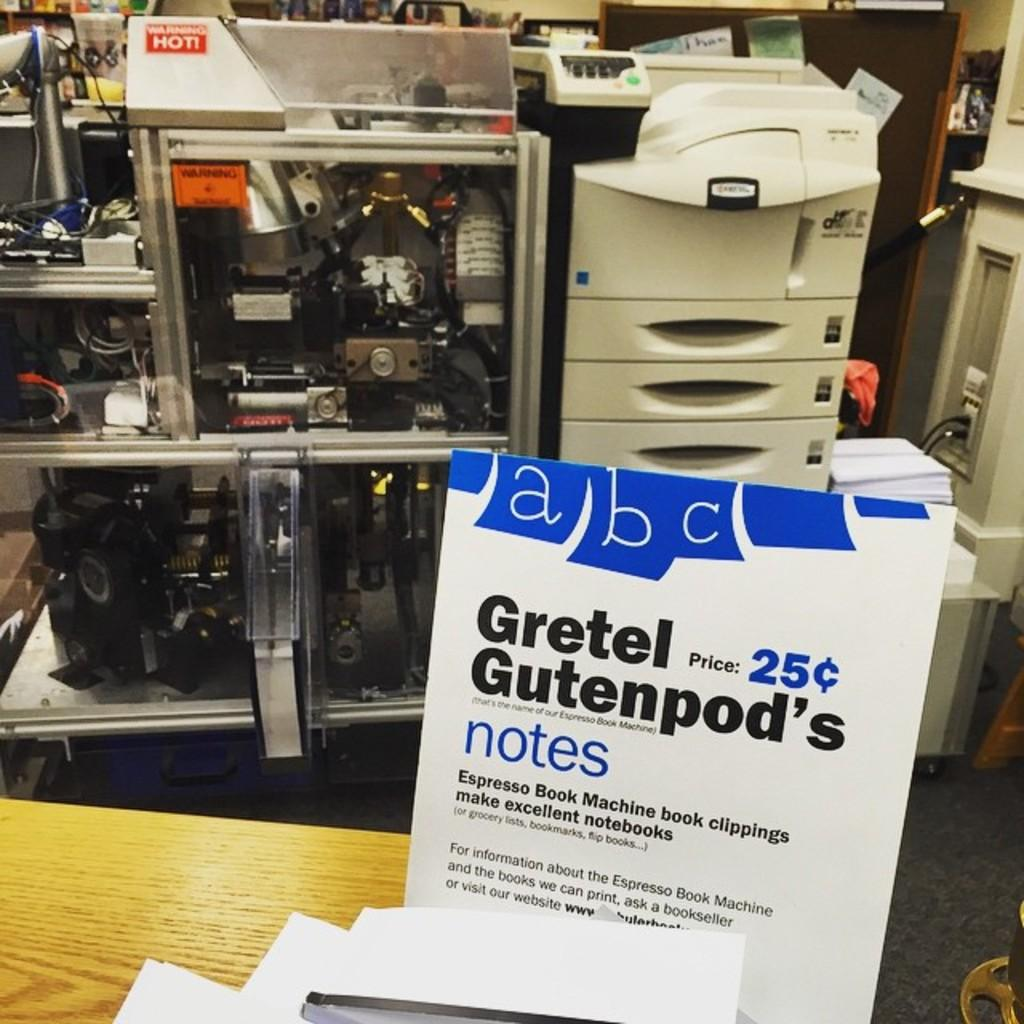What is the main object in the image? There is a board in the image. What is present on the table in the image? There are papers on the table. What can be seen in the background of the image? There are machines and devices in the background. Are there any papers on the machines or devices? Yes, there are papers on the machines or devices. What type of drum can be heard playing in the background of the image? There is no drum or sound present in the image; it is a still image. 